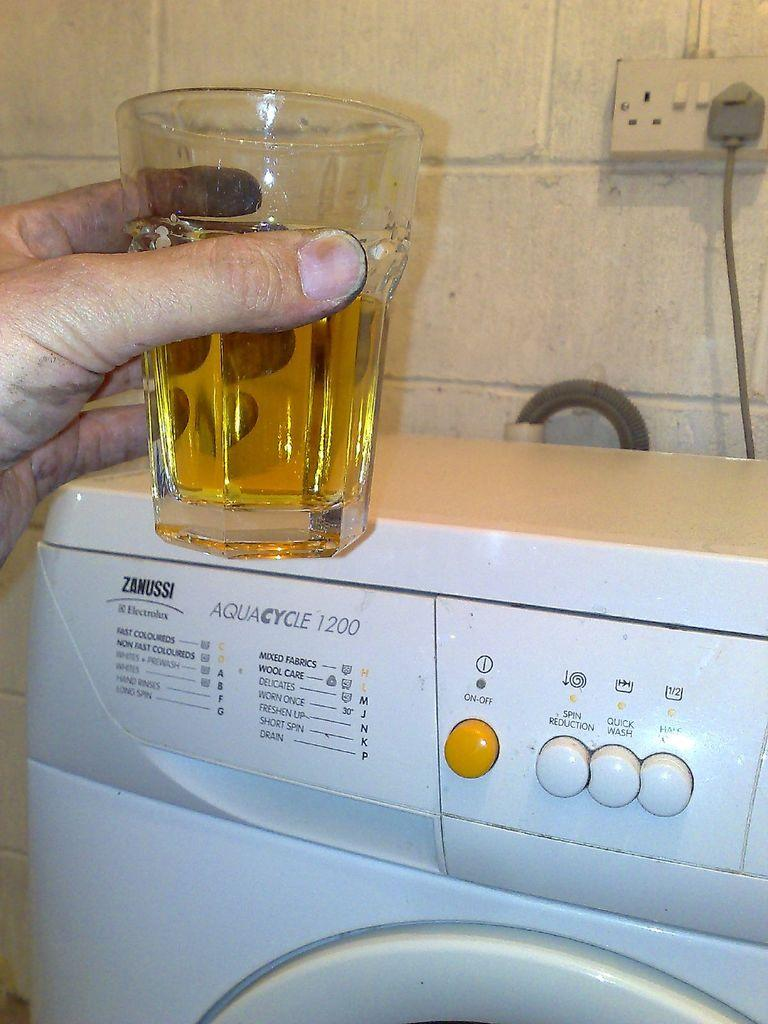<image>
Relay a brief, clear account of the picture shown. A Zanussi Electrolux washer with an Aquacycle 1200 